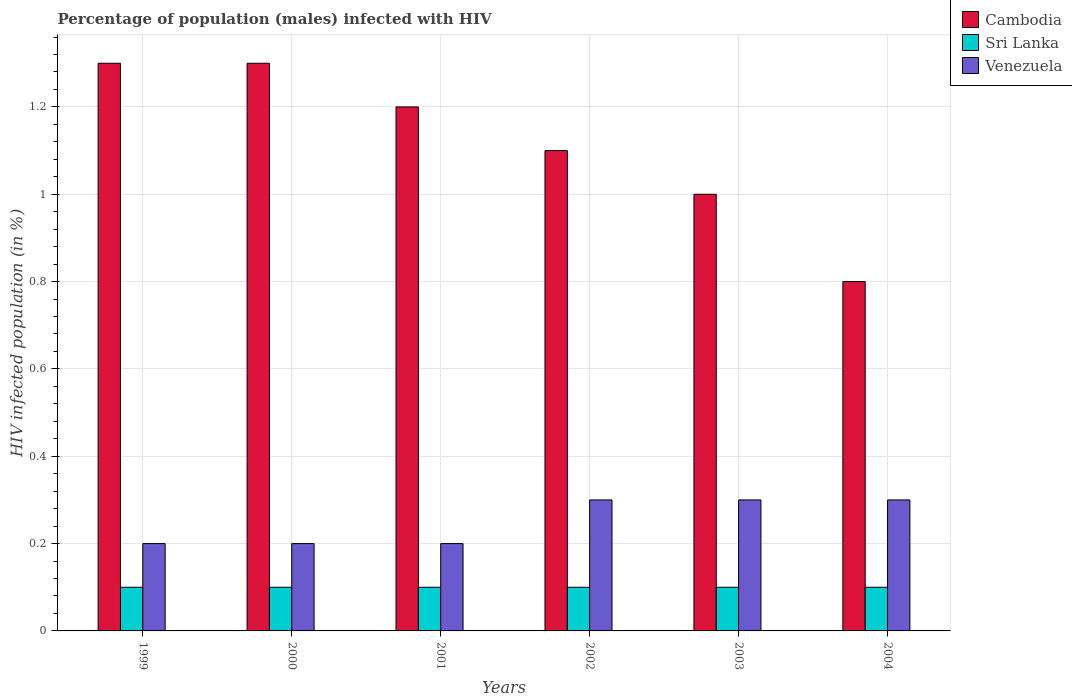How many different coloured bars are there?
Your answer should be very brief. 3. Are the number of bars per tick equal to the number of legend labels?
Offer a very short reply. Yes. Are the number of bars on each tick of the X-axis equal?
Your response must be concise. Yes. How many bars are there on the 2nd tick from the left?
Your answer should be compact. 3. What is the label of the 3rd group of bars from the left?
Keep it short and to the point. 2001. In how many cases, is the number of bars for a given year not equal to the number of legend labels?
Make the answer very short. 0. In which year was the percentage of HIV infected male population in Cambodia maximum?
Ensure brevity in your answer.  1999. In which year was the percentage of HIV infected male population in Sri Lanka minimum?
Provide a succinct answer. 1999. What is the total percentage of HIV infected male population in Venezuela in the graph?
Keep it short and to the point. 1.5. What is the difference between the percentage of HIV infected male population in Sri Lanka in 2001 and the percentage of HIV infected male population in Venezuela in 2004?
Keep it short and to the point. -0.2. What is the average percentage of HIV infected male population in Cambodia per year?
Your answer should be very brief. 1.12. In the year 2002, what is the difference between the percentage of HIV infected male population in Cambodia and percentage of HIV infected male population in Sri Lanka?
Your answer should be very brief. 1. What is the ratio of the percentage of HIV infected male population in Venezuela in 2000 to that in 2002?
Make the answer very short. 0.67. Is the difference between the percentage of HIV infected male population in Cambodia in 2000 and 2004 greater than the difference between the percentage of HIV infected male population in Sri Lanka in 2000 and 2004?
Offer a very short reply. Yes. What is the difference between the highest and the second highest percentage of HIV infected male population in Venezuela?
Offer a terse response. 0. What is the difference between the highest and the lowest percentage of HIV infected male population in Sri Lanka?
Your answer should be very brief. 0. In how many years, is the percentage of HIV infected male population in Sri Lanka greater than the average percentage of HIV infected male population in Sri Lanka taken over all years?
Your answer should be very brief. 6. What does the 2nd bar from the left in 2000 represents?
Offer a very short reply. Sri Lanka. What does the 3rd bar from the right in 2004 represents?
Make the answer very short. Cambodia. Is it the case that in every year, the sum of the percentage of HIV infected male population in Venezuela and percentage of HIV infected male population in Sri Lanka is greater than the percentage of HIV infected male population in Cambodia?
Keep it short and to the point. No. Are all the bars in the graph horizontal?
Your response must be concise. No. Are the values on the major ticks of Y-axis written in scientific E-notation?
Keep it short and to the point. No. How many legend labels are there?
Make the answer very short. 3. What is the title of the graph?
Ensure brevity in your answer.  Percentage of population (males) infected with HIV. What is the label or title of the Y-axis?
Provide a short and direct response. HIV infected population (in %). What is the HIV infected population (in %) of Cambodia in 2001?
Ensure brevity in your answer.  1.2. What is the HIV infected population (in %) of Sri Lanka in 2001?
Offer a terse response. 0.1. What is the HIV infected population (in %) in Sri Lanka in 2002?
Ensure brevity in your answer.  0.1. What is the HIV infected population (in %) of Venezuela in 2004?
Make the answer very short. 0.3. Across all years, what is the minimum HIV infected population (in %) of Cambodia?
Offer a very short reply. 0.8. What is the total HIV infected population (in %) of Cambodia in the graph?
Provide a short and direct response. 6.7. What is the total HIV infected population (in %) of Venezuela in the graph?
Give a very brief answer. 1.5. What is the difference between the HIV infected population (in %) in Sri Lanka in 1999 and that in 2000?
Provide a short and direct response. 0. What is the difference between the HIV infected population (in %) of Venezuela in 1999 and that in 2000?
Give a very brief answer. 0. What is the difference between the HIV infected population (in %) in Cambodia in 1999 and that in 2001?
Provide a succinct answer. 0.1. What is the difference between the HIV infected population (in %) of Cambodia in 1999 and that in 2002?
Offer a very short reply. 0.2. What is the difference between the HIV infected population (in %) in Sri Lanka in 1999 and that in 2003?
Provide a short and direct response. 0. What is the difference between the HIV infected population (in %) in Cambodia in 1999 and that in 2004?
Keep it short and to the point. 0.5. What is the difference between the HIV infected population (in %) of Sri Lanka in 1999 and that in 2004?
Your answer should be compact. 0. What is the difference between the HIV infected population (in %) of Venezuela in 1999 and that in 2004?
Your answer should be very brief. -0.1. What is the difference between the HIV infected population (in %) in Sri Lanka in 2000 and that in 2001?
Keep it short and to the point. 0. What is the difference between the HIV infected population (in %) of Sri Lanka in 2000 and that in 2003?
Ensure brevity in your answer.  0. What is the difference between the HIV infected population (in %) in Cambodia in 2000 and that in 2004?
Give a very brief answer. 0.5. What is the difference between the HIV infected population (in %) of Cambodia in 2001 and that in 2002?
Offer a very short reply. 0.1. What is the difference between the HIV infected population (in %) of Sri Lanka in 2001 and that in 2002?
Offer a very short reply. 0. What is the difference between the HIV infected population (in %) in Venezuela in 2001 and that in 2002?
Offer a very short reply. -0.1. What is the difference between the HIV infected population (in %) in Sri Lanka in 2001 and that in 2003?
Your answer should be compact. 0. What is the difference between the HIV infected population (in %) in Venezuela in 2001 and that in 2003?
Offer a very short reply. -0.1. What is the difference between the HIV infected population (in %) in Venezuela in 2001 and that in 2004?
Make the answer very short. -0.1. What is the difference between the HIV infected population (in %) of Cambodia in 2002 and that in 2004?
Offer a terse response. 0.3. What is the difference between the HIV infected population (in %) in Venezuela in 2002 and that in 2004?
Your answer should be compact. 0. What is the difference between the HIV infected population (in %) of Cambodia in 2003 and that in 2004?
Ensure brevity in your answer.  0.2. What is the difference between the HIV infected population (in %) of Cambodia in 1999 and the HIV infected population (in %) of Sri Lanka in 2000?
Offer a very short reply. 1.2. What is the difference between the HIV infected population (in %) of Sri Lanka in 1999 and the HIV infected population (in %) of Venezuela in 2000?
Provide a succinct answer. -0.1. What is the difference between the HIV infected population (in %) of Cambodia in 1999 and the HIV infected population (in %) of Venezuela in 2001?
Your answer should be very brief. 1.1. What is the difference between the HIV infected population (in %) of Cambodia in 1999 and the HIV infected population (in %) of Sri Lanka in 2002?
Keep it short and to the point. 1.2. What is the difference between the HIV infected population (in %) of Cambodia in 1999 and the HIV infected population (in %) of Sri Lanka in 2003?
Give a very brief answer. 1.2. What is the difference between the HIV infected population (in %) of Cambodia in 1999 and the HIV infected population (in %) of Venezuela in 2003?
Ensure brevity in your answer.  1. What is the difference between the HIV infected population (in %) of Cambodia in 1999 and the HIV infected population (in %) of Sri Lanka in 2004?
Provide a short and direct response. 1.2. What is the difference between the HIV infected population (in %) in Sri Lanka in 2000 and the HIV infected population (in %) in Venezuela in 2001?
Make the answer very short. -0.1. What is the difference between the HIV infected population (in %) of Cambodia in 2000 and the HIV infected population (in %) of Sri Lanka in 2002?
Your response must be concise. 1.2. What is the difference between the HIV infected population (in %) of Cambodia in 2000 and the HIV infected population (in %) of Venezuela in 2002?
Your answer should be very brief. 1. What is the difference between the HIV infected population (in %) of Sri Lanka in 2000 and the HIV infected population (in %) of Venezuela in 2002?
Your answer should be very brief. -0.2. What is the difference between the HIV infected population (in %) in Cambodia in 2000 and the HIV infected population (in %) in Sri Lanka in 2003?
Offer a very short reply. 1.2. What is the difference between the HIV infected population (in %) in Sri Lanka in 2000 and the HIV infected population (in %) in Venezuela in 2003?
Your answer should be very brief. -0.2. What is the difference between the HIV infected population (in %) of Cambodia in 2000 and the HIV infected population (in %) of Sri Lanka in 2004?
Provide a succinct answer. 1.2. What is the difference between the HIV infected population (in %) of Sri Lanka in 2000 and the HIV infected population (in %) of Venezuela in 2004?
Provide a short and direct response. -0.2. What is the difference between the HIV infected population (in %) in Cambodia in 2001 and the HIV infected population (in %) in Venezuela in 2003?
Offer a very short reply. 0.9. What is the difference between the HIV infected population (in %) of Cambodia in 2001 and the HIV infected population (in %) of Venezuela in 2004?
Give a very brief answer. 0.9. What is the difference between the HIV infected population (in %) in Cambodia in 2002 and the HIV infected population (in %) in Venezuela in 2003?
Make the answer very short. 0.8. What is the difference between the HIV infected population (in %) of Sri Lanka in 2002 and the HIV infected population (in %) of Venezuela in 2003?
Offer a terse response. -0.2. What is the difference between the HIV infected population (in %) of Cambodia in 2002 and the HIV infected population (in %) of Sri Lanka in 2004?
Offer a terse response. 1. What is the difference between the HIV infected population (in %) in Cambodia in 2002 and the HIV infected population (in %) in Venezuela in 2004?
Your answer should be compact. 0.8. What is the difference between the HIV infected population (in %) of Cambodia in 2003 and the HIV infected population (in %) of Venezuela in 2004?
Provide a succinct answer. 0.7. What is the difference between the HIV infected population (in %) in Sri Lanka in 2003 and the HIV infected population (in %) in Venezuela in 2004?
Give a very brief answer. -0.2. What is the average HIV infected population (in %) in Cambodia per year?
Offer a terse response. 1.12. What is the average HIV infected population (in %) of Sri Lanka per year?
Give a very brief answer. 0.1. In the year 1999, what is the difference between the HIV infected population (in %) of Cambodia and HIV infected population (in %) of Venezuela?
Offer a terse response. 1.1. In the year 2000, what is the difference between the HIV infected population (in %) in Cambodia and HIV infected population (in %) in Sri Lanka?
Ensure brevity in your answer.  1.2. In the year 2001, what is the difference between the HIV infected population (in %) in Cambodia and HIV infected population (in %) in Sri Lanka?
Your answer should be compact. 1.1. In the year 2004, what is the difference between the HIV infected population (in %) in Cambodia and HIV infected population (in %) in Sri Lanka?
Offer a terse response. 0.7. In the year 2004, what is the difference between the HIV infected population (in %) of Cambodia and HIV infected population (in %) of Venezuela?
Offer a terse response. 0.5. What is the ratio of the HIV infected population (in %) of Sri Lanka in 1999 to that in 2000?
Provide a short and direct response. 1. What is the ratio of the HIV infected population (in %) of Cambodia in 1999 to that in 2002?
Your answer should be compact. 1.18. What is the ratio of the HIV infected population (in %) of Sri Lanka in 1999 to that in 2002?
Provide a succinct answer. 1. What is the ratio of the HIV infected population (in %) in Venezuela in 1999 to that in 2003?
Your answer should be very brief. 0.67. What is the ratio of the HIV infected population (in %) of Cambodia in 1999 to that in 2004?
Offer a terse response. 1.62. What is the ratio of the HIV infected population (in %) in Venezuela in 1999 to that in 2004?
Ensure brevity in your answer.  0.67. What is the ratio of the HIV infected population (in %) of Cambodia in 2000 to that in 2001?
Your answer should be very brief. 1.08. What is the ratio of the HIV infected population (in %) of Sri Lanka in 2000 to that in 2001?
Ensure brevity in your answer.  1. What is the ratio of the HIV infected population (in %) of Venezuela in 2000 to that in 2001?
Keep it short and to the point. 1. What is the ratio of the HIV infected population (in %) of Cambodia in 2000 to that in 2002?
Offer a terse response. 1.18. What is the ratio of the HIV infected population (in %) of Venezuela in 2000 to that in 2002?
Provide a short and direct response. 0.67. What is the ratio of the HIV infected population (in %) in Sri Lanka in 2000 to that in 2003?
Keep it short and to the point. 1. What is the ratio of the HIV infected population (in %) in Cambodia in 2000 to that in 2004?
Provide a succinct answer. 1.62. What is the ratio of the HIV infected population (in %) in Sri Lanka in 2000 to that in 2004?
Your response must be concise. 1. What is the ratio of the HIV infected population (in %) in Venezuela in 2000 to that in 2004?
Provide a short and direct response. 0.67. What is the ratio of the HIV infected population (in %) in Sri Lanka in 2001 to that in 2002?
Your answer should be compact. 1. What is the ratio of the HIV infected population (in %) in Cambodia in 2001 to that in 2003?
Offer a terse response. 1.2. What is the ratio of the HIV infected population (in %) in Venezuela in 2001 to that in 2003?
Provide a short and direct response. 0.67. What is the ratio of the HIV infected population (in %) in Cambodia in 2001 to that in 2004?
Your answer should be compact. 1.5. What is the ratio of the HIV infected population (in %) of Sri Lanka in 2001 to that in 2004?
Offer a terse response. 1. What is the ratio of the HIV infected population (in %) of Cambodia in 2002 to that in 2003?
Offer a very short reply. 1.1. What is the ratio of the HIV infected population (in %) in Sri Lanka in 2002 to that in 2003?
Ensure brevity in your answer.  1. What is the ratio of the HIV infected population (in %) of Cambodia in 2002 to that in 2004?
Offer a very short reply. 1.38. What is the difference between the highest and the second highest HIV infected population (in %) of Cambodia?
Your answer should be compact. 0. What is the difference between the highest and the second highest HIV infected population (in %) of Sri Lanka?
Your answer should be compact. 0. What is the difference between the highest and the second highest HIV infected population (in %) of Venezuela?
Keep it short and to the point. 0. What is the difference between the highest and the lowest HIV infected population (in %) in Cambodia?
Make the answer very short. 0.5. What is the difference between the highest and the lowest HIV infected population (in %) of Sri Lanka?
Your answer should be compact. 0. What is the difference between the highest and the lowest HIV infected population (in %) in Venezuela?
Provide a short and direct response. 0.1. 